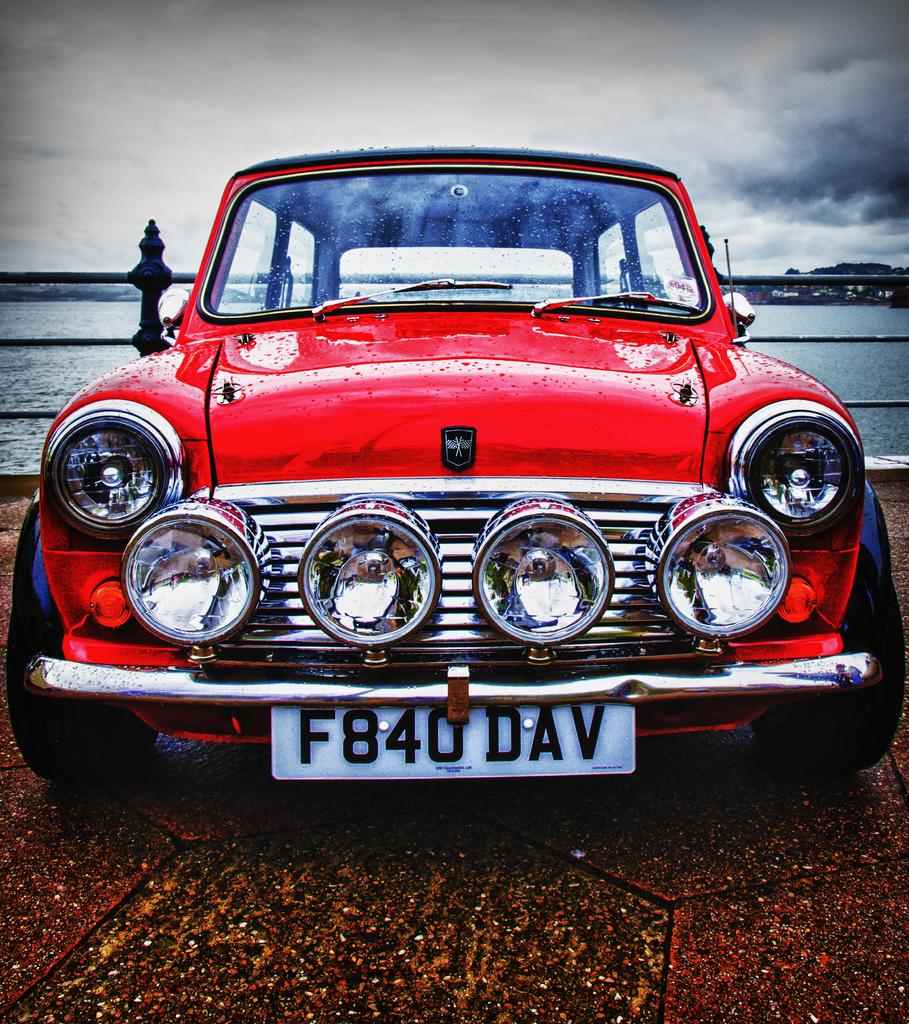What is the color of the wall on the ground in the image? The wall on the ground in the image is red. What can be seen in the background of the image? There is a fence, water, and the sky visible in the background of the image. What type of church can be seen in the image? There is no church present in the image. Who is the creator of the fence in the image? The creator of the fence is not mentioned or visible in the image. 